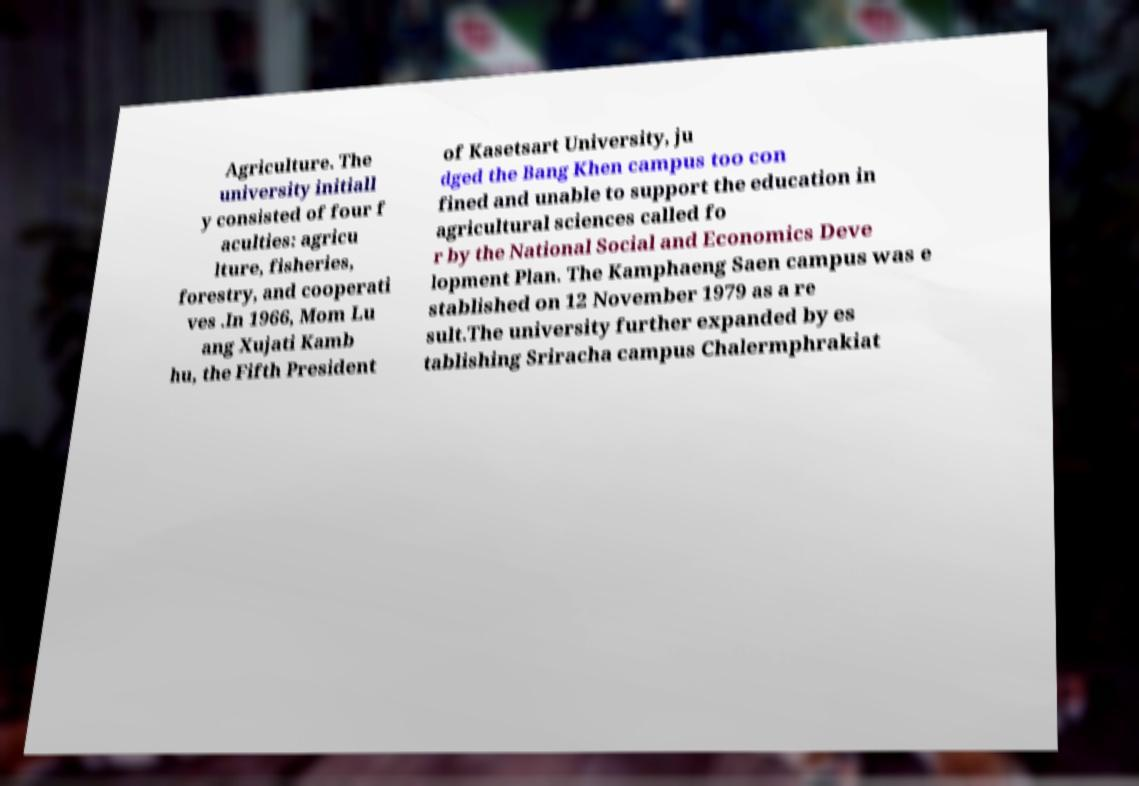There's text embedded in this image that I need extracted. Can you transcribe it verbatim? Agriculture. The university initiall y consisted of four f aculties: agricu lture, fisheries, forestry, and cooperati ves .In 1966, Mom Lu ang Xujati Kamb hu, the Fifth President of Kasetsart University, ju dged the Bang Khen campus too con fined and unable to support the education in agricultural sciences called fo r by the National Social and Economics Deve lopment Plan. The Kamphaeng Saen campus was e stablished on 12 November 1979 as a re sult.The university further expanded by es tablishing Sriracha campus Chalermphrakiat 